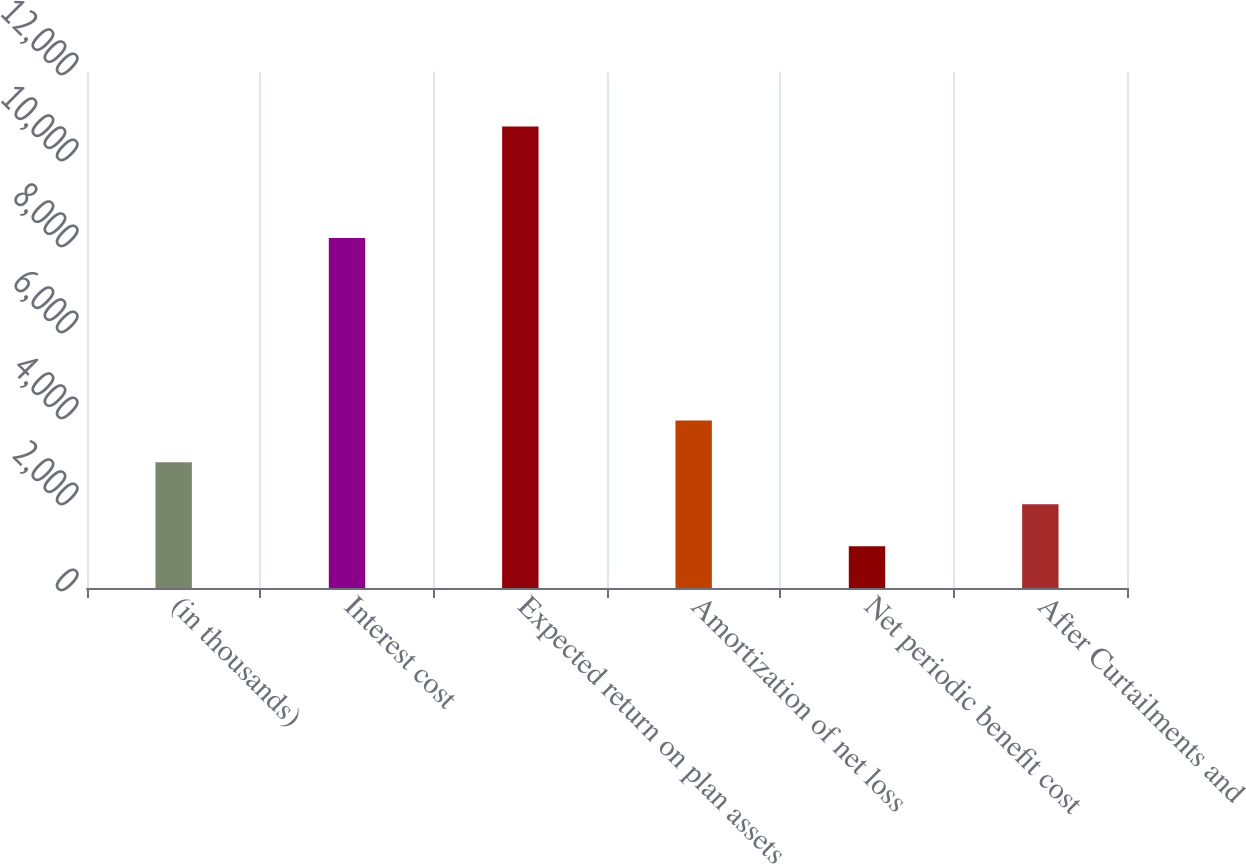Convert chart. <chart><loc_0><loc_0><loc_500><loc_500><bar_chart><fcel>(in thousands)<fcel>Interest cost<fcel>Expected return on plan assets<fcel>Amortization of net loss<fcel>Net periodic benefit cost<fcel>After Curtailments and<nl><fcel>2921.8<fcel>8139<fcel>10733<fcel>3898.2<fcel>969<fcel>1945.4<nl></chart> 